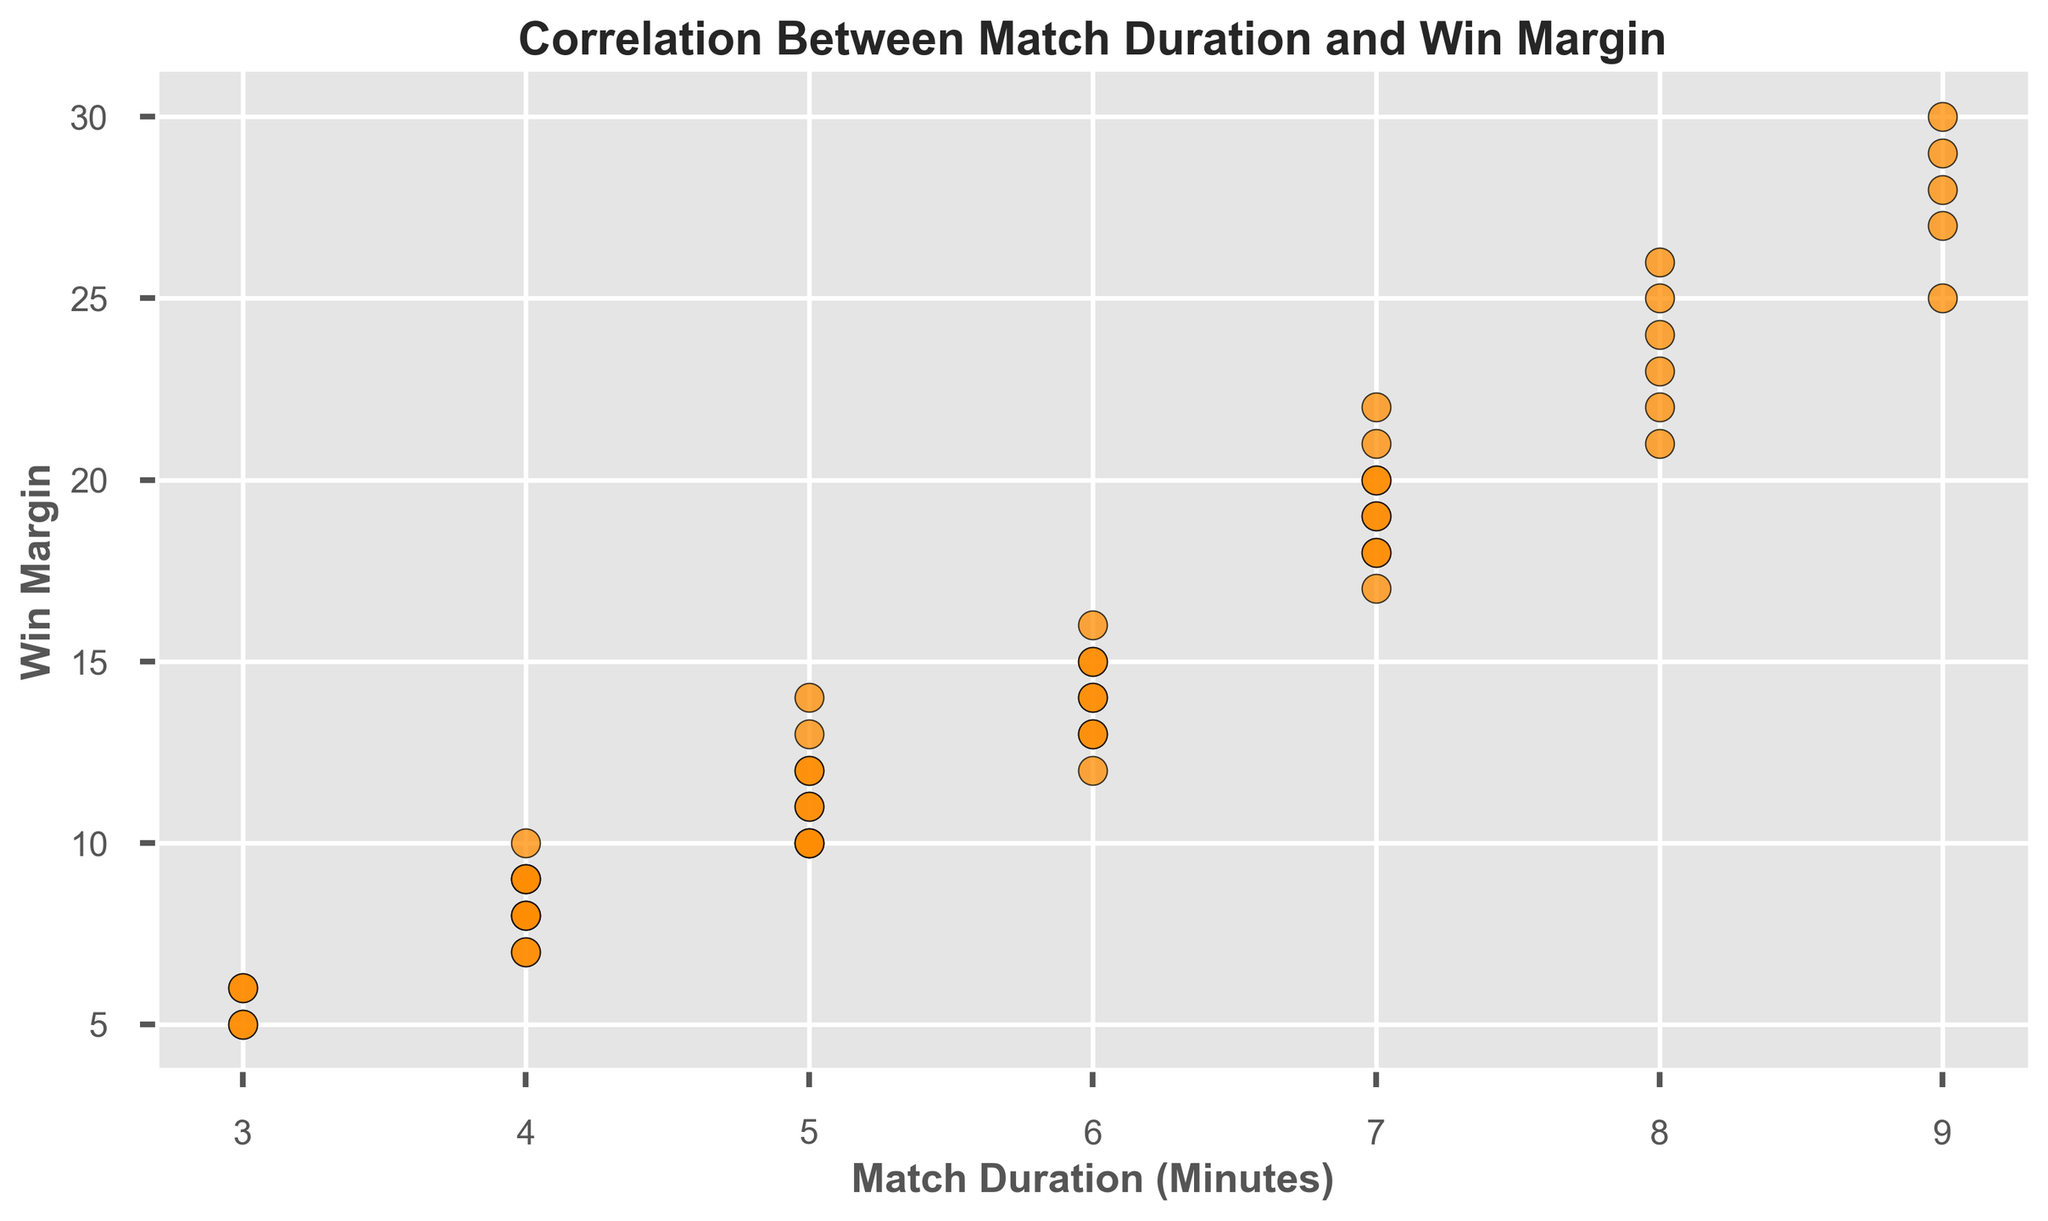What is the range of the Win Margin for matches that last 6 minutes? The Win Margin for matches that last 6 minutes can be seen directly from the scatter plot. By identifying all points at 6 minutes on the x-axis, we observe the corresponding y-values. The Win Margins at this duration are 15, 12, 13, 14, and 16, therefore the range is 16 - 12 = 4.
Answer: 4 How many matches lasted for exactly 7 minutes? To determine the number of matches that lasted 7 minutes, we count all points where the x-value is 7 on the scatter plot. Counting the number of such points gives 6 matches.
Answer: 6 What is the highest Win Margin and the corresponding match duration? Look for the point with the highest y-value on the scatter plot. The highest Win Margin is 30, which appears at a match duration of 9 minutes.
Answer: 30, 9 minutes Which match durations have Win Margins that exceed 20? By scanning the scatter plot for points where the y-value is greater than 20, we observe that these points occur at match durations of 8, 9, and 7 minutes.
Answer: 8, 9, 7 minutes Is there any match duration that corresponds to exactly 5 different Win Margins? Identify which x-values (match durations) have exactly 5 points (Win Margins). The scatter plot shows that a match duration of 6 minutes corresponds to 5 different points (12, 13, 14, 15, 16).
Answer: Yes, 6 minutes Do shorter matches generally have smaller Win Margins? Observing the scatter plot, it is evident that the points with lower match durations (e.g., 3, 4, 5 minutes) tend to align with lower Win Margins compared to points with higher match durations. Therefore, shorter matches generally have smaller Win Margins.
Answer: Yes Which match duration has the most diverse range of Win Margins? The match duration with the most diverse range of Win Margins can be determined by finding the x-value with the largest spread in y-values. Here, match duration of 9 minutes shows a range from 25 to 30, giving a spread of 5, which appears to be the largest in the data.
Answer: 9 minutes What is the average Win Margin for matches that last 8 minutes? From the scatter plot, the Win Margins for matches lasting 8 minutes are 25, 22, 23, 24, 26, and 21. Adding these values gives 141. Dividing by the number of points (6) gives an average of 141/6 = 23.5.
Answer: 23.5 Compare the average Win Margins for matches that last 5 and 7 minutes. For 5 minutes: The Win Margins are 10, 14, 11, 12, 10, and 13. Sum is 70, average is 70/6 = 11.67. For 7 minutes: The Win Margins are 20, 18, 17, 19, 21, and 22. Sum is 117, average is 117/6 = 19.5. Comparison indicates that matches lasting 7 minutes have a higher average Win Margin compared to those lasting 5 minutes.
Answer: 7 minutes: 19.5, 5 minutes: 11.67 Is there a visible trend between match duration and Win Margin? Observing the scatter plot, we notice that as match duration increases, so do the Win Margins. This indicates a positive correlation, suggesting that longer matches tend to have larger Win Margins.
Answer: Yes, positive correlation 